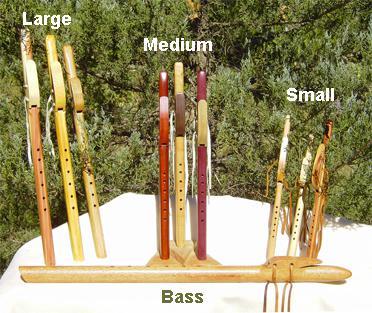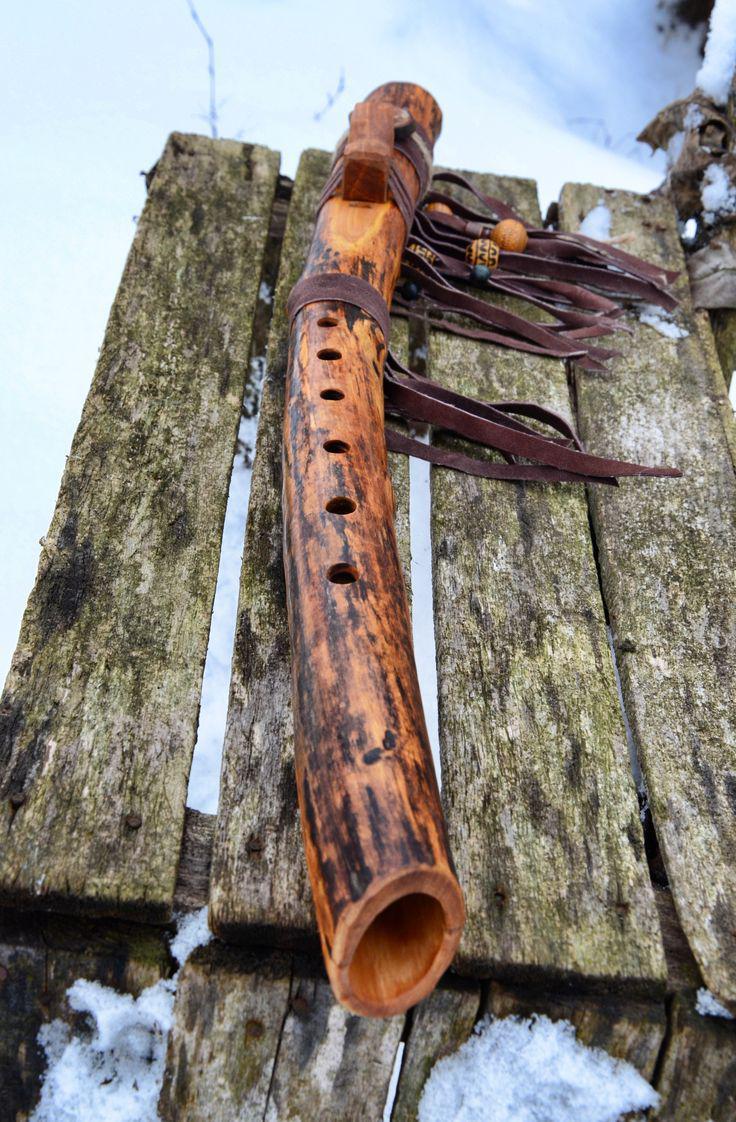The first image is the image on the left, the second image is the image on the right. For the images displayed, is the sentence "There are less than three instruments in the right image." factually correct? Answer yes or no. Yes. The first image is the image on the left, the second image is the image on the right. Assess this claim about the two images: "The right image shows a rustic curved wooden flute with brown straps at its top, and it is displayed end-first.". Correct or not? Answer yes or no. Yes. 